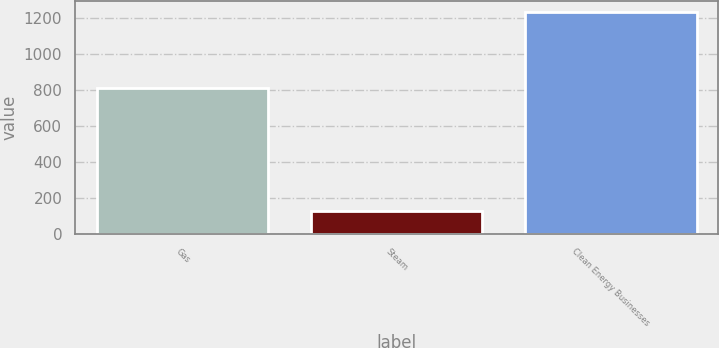Convert chart. <chart><loc_0><loc_0><loc_500><loc_500><bar_chart><fcel>Gas<fcel>Steam<fcel>Clean Energy Businesses<nl><fcel>811<fcel>126<fcel>1235<nl></chart> 